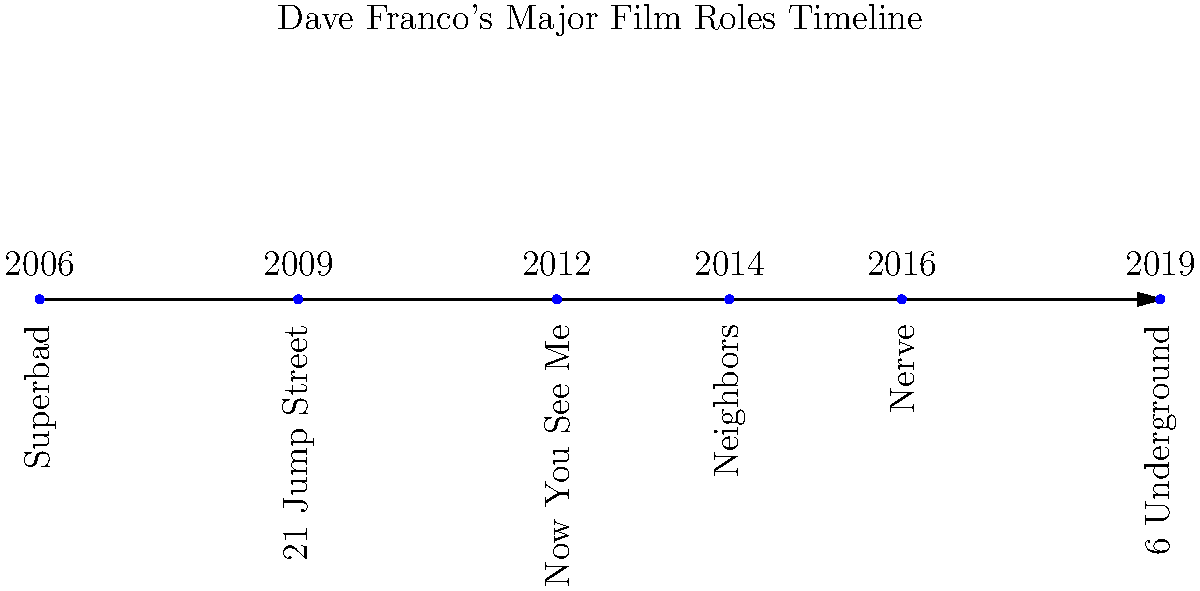Based on the timeline of Dave Franco's major film roles, which movie marked his breakthrough in the comedy genre, and how many years after his debut in "Superbad" did this film release? To answer this question, we need to follow these steps:

1. Identify Dave Franco's debut film on the timeline: "Superbad" in 2006.

2. Recognize that "21 Jump Street" in 2009 was his breakthrough in the comedy genre. This film was a major box office success and established Franco as a comedic actor.

3. Calculate the time difference between "Superbad" and "21 Jump Street":
   2009 (21 Jump Street) - 2006 (Superbad) = 3 years

Therefore, Dave Franco's breakthrough in the comedy genre came 3 years after his debut in "Superbad".
Answer: 21 Jump Street, 3 years 